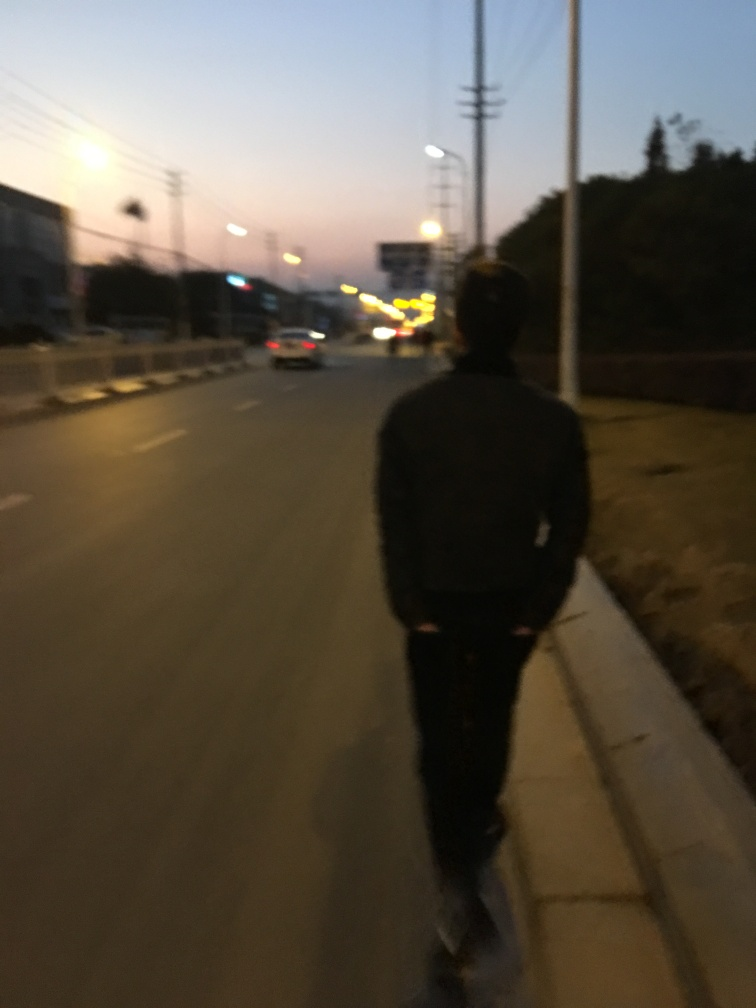What atmosphere does the image evoke and why? The image exudes a serene and somewhat solitary atmosphere. The quiet street with minimal traffic, combined with the soft, dim light of dusk, sets a peaceful mood, almost inviting contemplation. It's a scene that might resonate with viewers who appreciate the quiet moments of transition between day and night. 